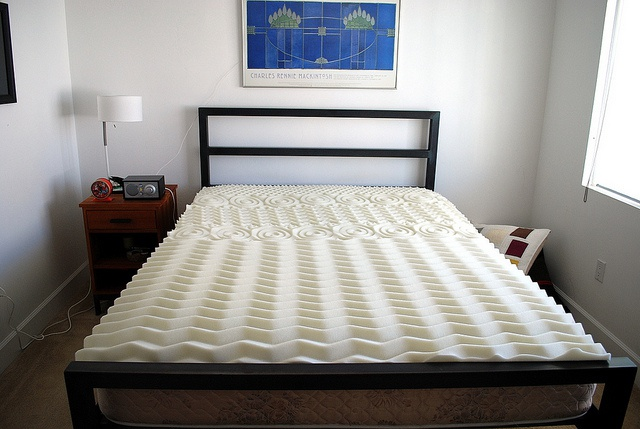Describe the objects in this image and their specific colors. I can see bed in darkgray, black, and lightgray tones and clock in darkgray, maroon, black, brown, and gray tones in this image. 